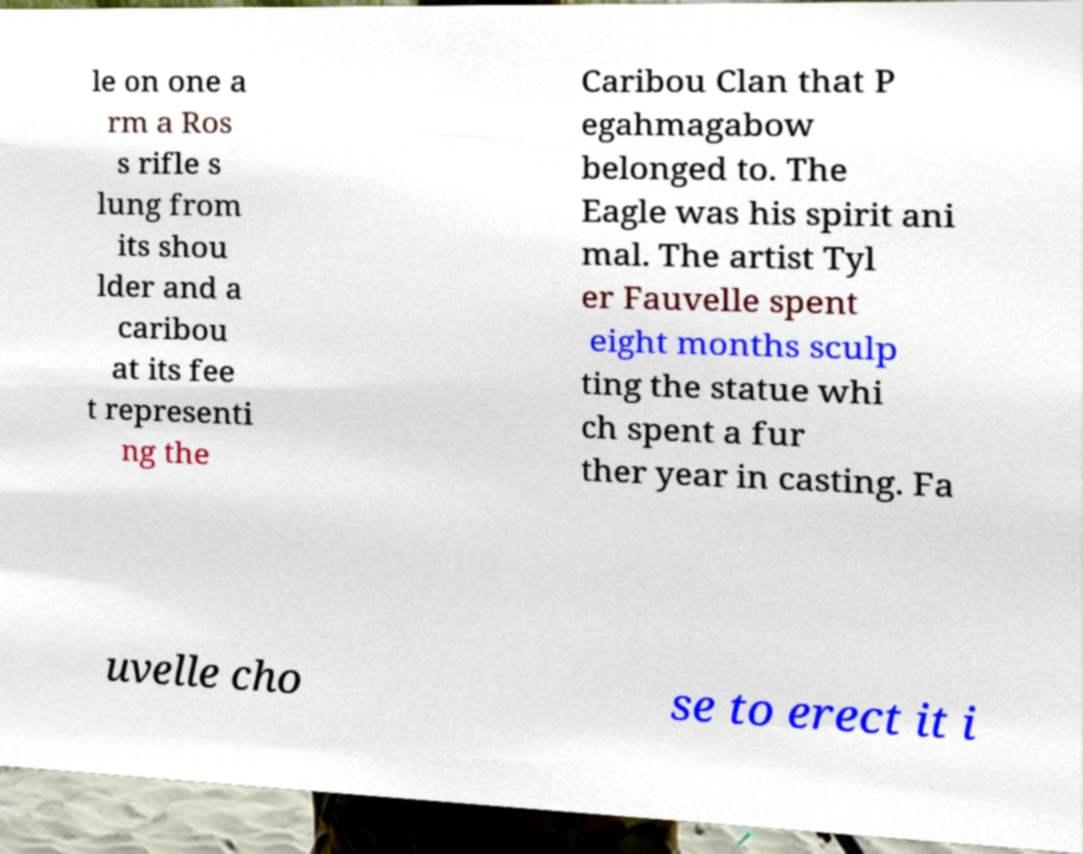Please identify and transcribe the text found in this image. le on one a rm a Ros s rifle s lung from its shou lder and a caribou at its fee t representi ng the Caribou Clan that P egahmagabow belonged to. The Eagle was his spirit ani mal. The artist Tyl er Fauvelle spent eight months sculp ting the statue whi ch spent a fur ther year in casting. Fa uvelle cho se to erect it i 